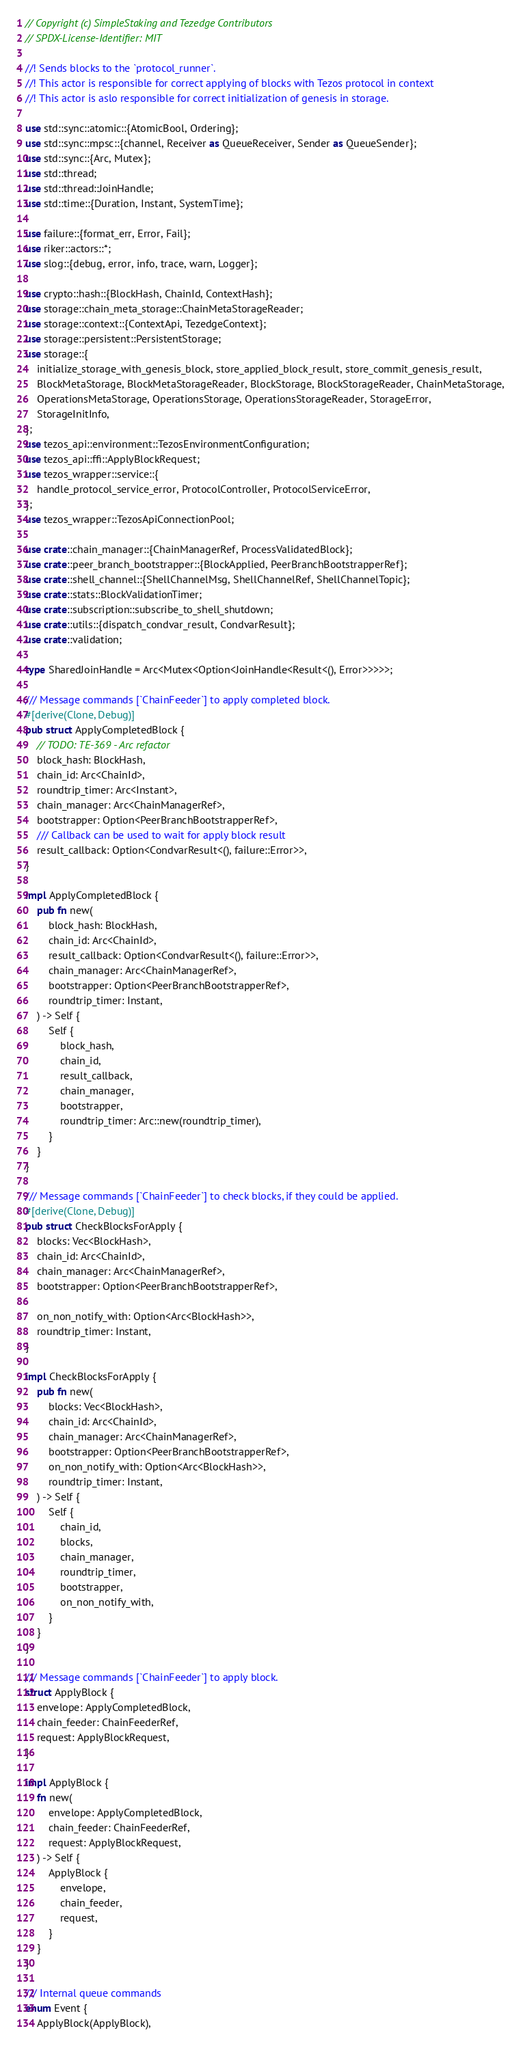<code> <loc_0><loc_0><loc_500><loc_500><_Rust_>// Copyright (c) SimpleStaking and Tezedge Contributors
// SPDX-License-Identifier: MIT

//! Sends blocks to the `protocol_runner`.
//! This actor is responsible for correct applying of blocks with Tezos protocol in context
//! This actor is aslo responsible for correct initialization of genesis in storage.

use std::sync::atomic::{AtomicBool, Ordering};
use std::sync::mpsc::{channel, Receiver as QueueReceiver, Sender as QueueSender};
use std::sync::{Arc, Mutex};
use std::thread;
use std::thread::JoinHandle;
use std::time::{Duration, Instant, SystemTime};

use failure::{format_err, Error, Fail};
use riker::actors::*;
use slog::{debug, error, info, trace, warn, Logger};

use crypto::hash::{BlockHash, ChainId, ContextHash};
use storage::chain_meta_storage::ChainMetaStorageReader;
use storage::context::{ContextApi, TezedgeContext};
use storage::persistent::PersistentStorage;
use storage::{
    initialize_storage_with_genesis_block, store_applied_block_result, store_commit_genesis_result,
    BlockMetaStorage, BlockMetaStorageReader, BlockStorage, BlockStorageReader, ChainMetaStorage,
    OperationsMetaStorage, OperationsStorage, OperationsStorageReader, StorageError,
    StorageInitInfo,
};
use tezos_api::environment::TezosEnvironmentConfiguration;
use tezos_api::ffi::ApplyBlockRequest;
use tezos_wrapper::service::{
    handle_protocol_service_error, ProtocolController, ProtocolServiceError,
};
use tezos_wrapper::TezosApiConnectionPool;

use crate::chain_manager::{ChainManagerRef, ProcessValidatedBlock};
use crate::peer_branch_bootstrapper::{BlockApplied, PeerBranchBootstrapperRef};
use crate::shell_channel::{ShellChannelMsg, ShellChannelRef, ShellChannelTopic};
use crate::stats::BlockValidationTimer;
use crate::subscription::subscribe_to_shell_shutdown;
use crate::utils::{dispatch_condvar_result, CondvarResult};
use crate::validation;

type SharedJoinHandle = Arc<Mutex<Option<JoinHandle<Result<(), Error>>>>>;

/// Message commands [`ChainFeeder`] to apply completed block.
#[derive(Clone, Debug)]
pub struct ApplyCompletedBlock {
    // TODO: TE-369 - Arc refactor
    block_hash: BlockHash,
    chain_id: Arc<ChainId>,
    roundtrip_timer: Arc<Instant>,
    chain_manager: Arc<ChainManagerRef>,
    bootstrapper: Option<PeerBranchBootstrapperRef>,
    /// Callback can be used to wait for apply block result
    result_callback: Option<CondvarResult<(), failure::Error>>,
}

impl ApplyCompletedBlock {
    pub fn new(
        block_hash: BlockHash,
        chain_id: Arc<ChainId>,
        result_callback: Option<CondvarResult<(), failure::Error>>,
        chain_manager: Arc<ChainManagerRef>,
        bootstrapper: Option<PeerBranchBootstrapperRef>,
        roundtrip_timer: Instant,
    ) -> Self {
        Self {
            block_hash,
            chain_id,
            result_callback,
            chain_manager,
            bootstrapper,
            roundtrip_timer: Arc::new(roundtrip_timer),
        }
    }
}

/// Message commands [`ChainFeeder`] to check blocks, if they could be applied.
#[derive(Clone, Debug)]
pub struct CheckBlocksForApply {
    blocks: Vec<BlockHash>,
    chain_id: Arc<ChainId>,
    chain_manager: Arc<ChainManagerRef>,
    bootstrapper: Option<PeerBranchBootstrapperRef>,

    on_non_notify_with: Option<Arc<BlockHash>>,
    roundtrip_timer: Instant,
}

impl CheckBlocksForApply {
    pub fn new(
        blocks: Vec<BlockHash>,
        chain_id: Arc<ChainId>,
        chain_manager: Arc<ChainManagerRef>,
        bootstrapper: Option<PeerBranchBootstrapperRef>,
        on_non_notify_with: Option<Arc<BlockHash>>,
        roundtrip_timer: Instant,
    ) -> Self {
        Self {
            chain_id,
            blocks,
            chain_manager,
            roundtrip_timer,
            bootstrapper,
            on_non_notify_with,
        }
    }
}

/// Message commands [`ChainFeeder`] to apply block.
struct ApplyBlock {
    envelope: ApplyCompletedBlock,
    chain_feeder: ChainFeederRef,
    request: ApplyBlockRequest,
}

impl ApplyBlock {
    fn new(
        envelope: ApplyCompletedBlock,
        chain_feeder: ChainFeederRef,
        request: ApplyBlockRequest,
    ) -> Self {
        ApplyBlock {
            envelope,
            chain_feeder,
            request,
        }
    }
}

/// Internal queue commands
enum Event {
    ApplyBlock(ApplyBlock),</code> 